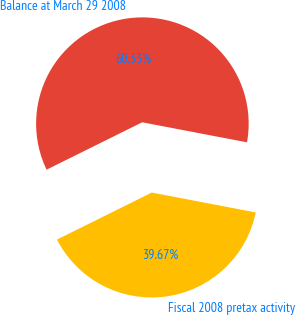Convert chart to OTSL. <chart><loc_0><loc_0><loc_500><loc_500><pie_chart><fcel>Fiscal 2008 pretax activity<fcel>Balance at March 29 2008<nl><fcel>39.67%<fcel>60.33%<nl></chart> 